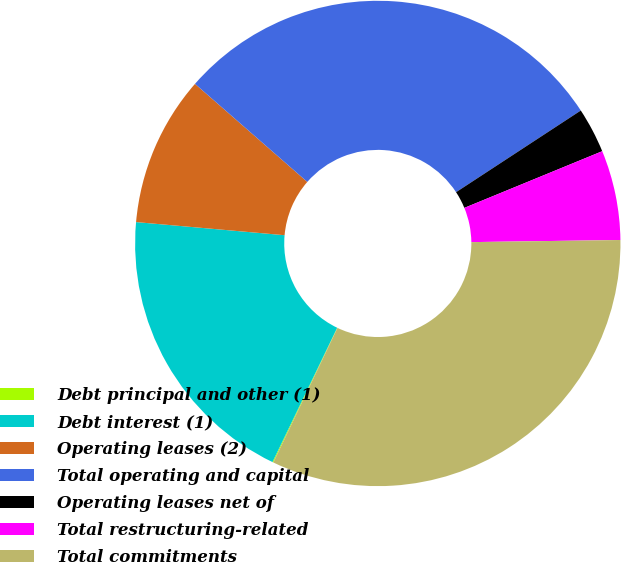<chart> <loc_0><loc_0><loc_500><loc_500><pie_chart><fcel>Debt principal and other (1)<fcel>Debt interest (1)<fcel>Operating leases (2)<fcel>Total operating and capital<fcel>Operating leases net of<fcel>Total restructuring-related<fcel>Total commitments<nl><fcel>0.06%<fcel>19.26%<fcel>10.02%<fcel>29.35%<fcel>3.02%<fcel>5.98%<fcel>32.31%<nl></chart> 